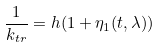Convert formula to latex. <formula><loc_0><loc_0><loc_500><loc_500>\frac { 1 } { k _ { t r } } = h ( 1 + \eta _ { 1 } ( t , \lambda ) )</formula> 